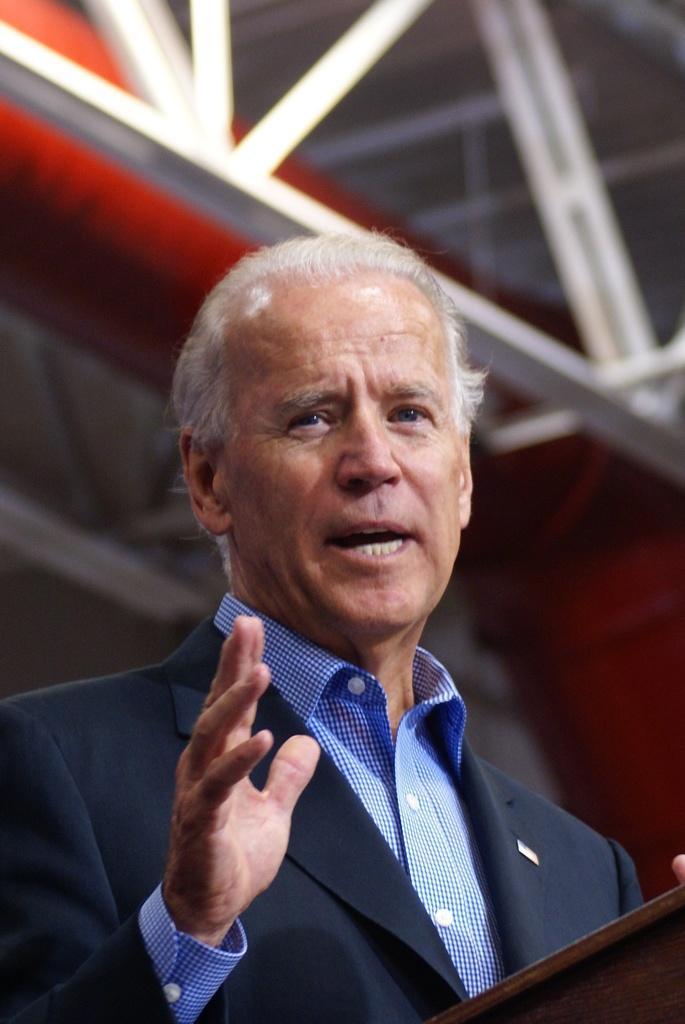Please provide a concise description of this image. In this picture I can observe a man standing in front of a podium. He is wearing blue color coat. Man is speaking. 